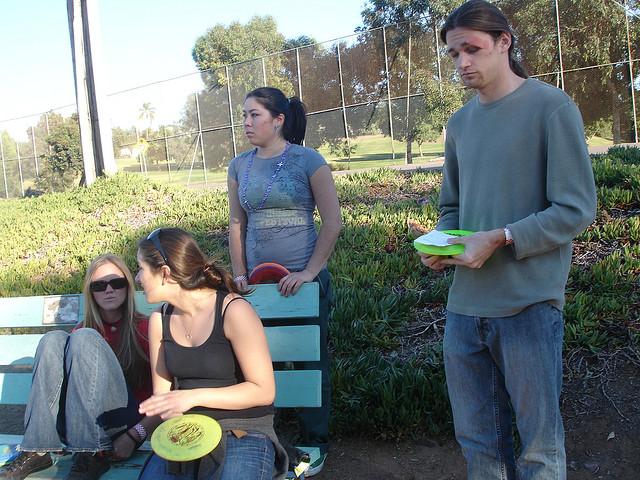What happened to the man's face?
Short answer required. Accident. What are these people holding?
Be succinct. Frisbees. Where was this photo taken?
Concise answer only. Park. 